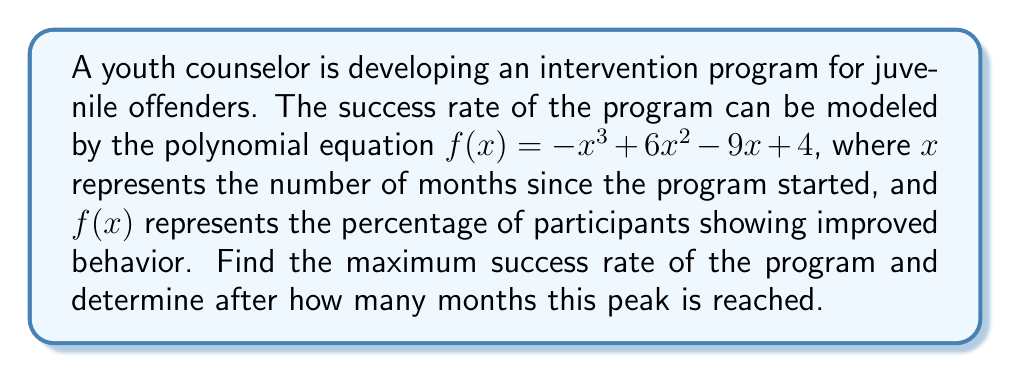Could you help me with this problem? 1) To find the maximum success rate, we need to find the local maximum of the function $f(x) = -x^3 + 6x^2 - 9x + 4$.

2) The local maximum occurs where the first derivative of $f(x)$ is zero. Let's find $f'(x)$:
   $f'(x) = -3x^2 + 12x - 9$

3) Set $f'(x) = 0$ and solve:
   $-3x^2 + 12x - 9 = 0$
   $-3(x^2 - 4x + 3) = 0$
   $-3(x - 1)(x - 3) = 0$

4) The solutions are $x = 1$ and $x = 3$. To determine which one is the maximum, we can check the second derivative:
   $f''(x) = -6x + 12$
   At $x = 1$: $f''(1) = 6 > 0$ (local minimum)
   At $x = 3$: $f''(3) = -6 < 0$ (local maximum)

5) Therefore, the maximum occurs at $x = 3$ months.

6) To find the maximum success rate, we evaluate $f(3)$:
   $f(3) = -(3)^3 + 6(3)^2 - 9(3) + 4$
         $= -27 + 54 - 27 + 4$
         $= 4$

Thus, the maximum success rate is 4%, reached after 3 months.
Answer: 4% after 3 months 